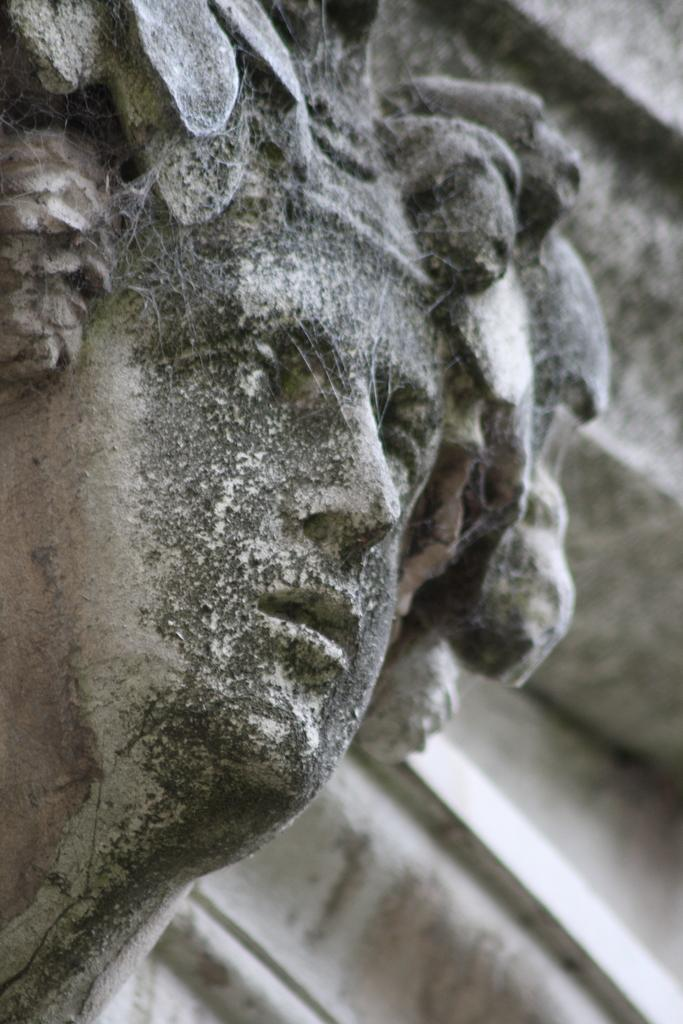What is the main subject of the image? There is a sculpture in the image. Are there any additional features on the sculpture? Yes, there are webs on the sculpture. Can you describe the background of the image? The background of the image is blurred. How many grapes are hanging from the sculpture in the image? There are no grapes present in the image; the sculpture has webs on it. What advice would the grandfather in the image give about the sculpture? There is no grandfather present in the image, so it is not possible to answer that question. 